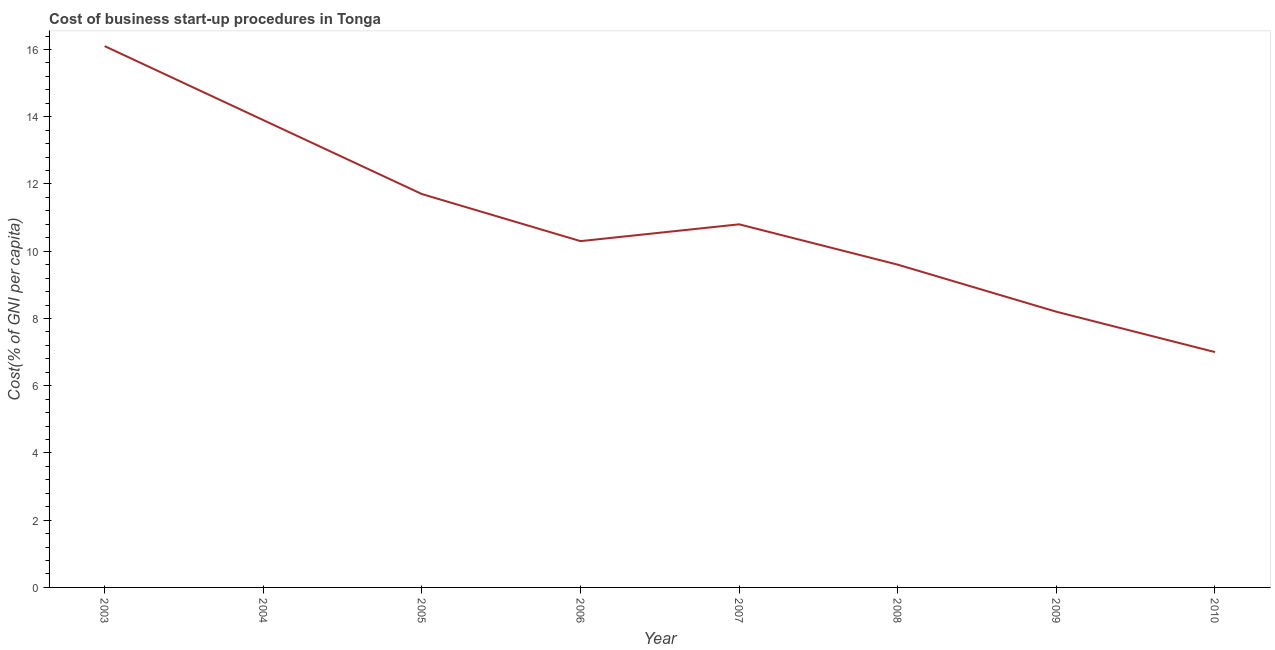What is the cost of business startup procedures in 2007?
Make the answer very short. 10.8. Across all years, what is the maximum cost of business startup procedures?
Your response must be concise. 16.1. Across all years, what is the minimum cost of business startup procedures?
Your response must be concise. 7. What is the sum of the cost of business startup procedures?
Your answer should be compact. 87.6. What is the difference between the cost of business startup procedures in 2005 and 2008?
Your answer should be compact. 2.1. What is the average cost of business startup procedures per year?
Make the answer very short. 10.95. What is the median cost of business startup procedures?
Your response must be concise. 10.55. What is the ratio of the cost of business startup procedures in 2004 to that in 2009?
Offer a very short reply. 1.7. Is the difference between the cost of business startup procedures in 2008 and 2010 greater than the difference between any two years?
Keep it short and to the point. No. What is the difference between the highest and the second highest cost of business startup procedures?
Give a very brief answer. 2.2. Is the sum of the cost of business startup procedures in 2003 and 2005 greater than the maximum cost of business startup procedures across all years?
Offer a terse response. Yes. What is the difference between the highest and the lowest cost of business startup procedures?
Offer a very short reply. 9.1. Does the cost of business startup procedures monotonically increase over the years?
Your response must be concise. No. How many lines are there?
Offer a very short reply. 1. What is the difference between two consecutive major ticks on the Y-axis?
Provide a succinct answer. 2. Does the graph contain any zero values?
Offer a very short reply. No. Does the graph contain grids?
Your answer should be compact. No. What is the title of the graph?
Your response must be concise. Cost of business start-up procedures in Tonga. What is the label or title of the Y-axis?
Give a very brief answer. Cost(% of GNI per capita). What is the Cost(% of GNI per capita) of 2004?
Ensure brevity in your answer.  13.9. What is the Cost(% of GNI per capita) in 2006?
Make the answer very short. 10.3. What is the Cost(% of GNI per capita) in 2007?
Provide a short and direct response. 10.8. What is the Cost(% of GNI per capita) in 2009?
Your answer should be compact. 8.2. What is the Cost(% of GNI per capita) of 2010?
Offer a terse response. 7. What is the difference between the Cost(% of GNI per capita) in 2003 and 2004?
Make the answer very short. 2.2. What is the difference between the Cost(% of GNI per capita) in 2003 and 2006?
Offer a very short reply. 5.8. What is the difference between the Cost(% of GNI per capita) in 2003 and 2007?
Offer a terse response. 5.3. What is the difference between the Cost(% of GNI per capita) in 2003 and 2009?
Offer a very short reply. 7.9. What is the difference between the Cost(% of GNI per capita) in 2003 and 2010?
Give a very brief answer. 9.1. What is the difference between the Cost(% of GNI per capita) in 2004 and 2009?
Your answer should be compact. 5.7. What is the difference between the Cost(% of GNI per capita) in 2004 and 2010?
Give a very brief answer. 6.9. What is the difference between the Cost(% of GNI per capita) in 2005 and 2007?
Offer a very short reply. 0.9. What is the difference between the Cost(% of GNI per capita) in 2005 and 2008?
Your response must be concise. 2.1. What is the difference between the Cost(% of GNI per capita) in 2005 and 2010?
Make the answer very short. 4.7. What is the difference between the Cost(% of GNI per capita) in 2006 and 2007?
Your answer should be very brief. -0.5. What is the difference between the Cost(% of GNI per capita) in 2006 and 2008?
Give a very brief answer. 0.7. What is the difference between the Cost(% of GNI per capita) in 2006 and 2009?
Ensure brevity in your answer.  2.1. What is the difference between the Cost(% of GNI per capita) in 2006 and 2010?
Your answer should be very brief. 3.3. What is the difference between the Cost(% of GNI per capita) in 2007 and 2008?
Ensure brevity in your answer.  1.2. What is the difference between the Cost(% of GNI per capita) in 2008 and 2009?
Ensure brevity in your answer.  1.4. What is the ratio of the Cost(% of GNI per capita) in 2003 to that in 2004?
Your answer should be very brief. 1.16. What is the ratio of the Cost(% of GNI per capita) in 2003 to that in 2005?
Offer a very short reply. 1.38. What is the ratio of the Cost(% of GNI per capita) in 2003 to that in 2006?
Give a very brief answer. 1.56. What is the ratio of the Cost(% of GNI per capita) in 2003 to that in 2007?
Give a very brief answer. 1.49. What is the ratio of the Cost(% of GNI per capita) in 2003 to that in 2008?
Offer a terse response. 1.68. What is the ratio of the Cost(% of GNI per capita) in 2003 to that in 2009?
Make the answer very short. 1.96. What is the ratio of the Cost(% of GNI per capita) in 2004 to that in 2005?
Your answer should be very brief. 1.19. What is the ratio of the Cost(% of GNI per capita) in 2004 to that in 2006?
Your answer should be compact. 1.35. What is the ratio of the Cost(% of GNI per capita) in 2004 to that in 2007?
Make the answer very short. 1.29. What is the ratio of the Cost(% of GNI per capita) in 2004 to that in 2008?
Provide a short and direct response. 1.45. What is the ratio of the Cost(% of GNI per capita) in 2004 to that in 2009?
Make the answer very short. 1.7. What is the ratio of the Cost(% of GNI per capita) in 2004 to that in 2010?
Keep it short and to the point. 1.99. What is the ratio of the Cost(% of GNI per capita) in 2005 to that in 2006?
Make the answer very short. 1.14. What is the ratio of the Cost(% of GNI per capita) in 2005 to that in 2007?
Provide a succinct answer. 1.08. What is the ratio of the Cost(% of GNI per capita) in 2005 to that in 2008?
Your answer should be compact. 1.22. What is the ratio of the Cost(% of GNI per capita) in 2005 to that in 2009?
Give a very brief answer. 1.43. What is the ratio of the Cost(% of GNI per capita) in 2005 to that in 2010?
Your answer should be compact. 1.67. What is the ratio of the Cost(% of GNI per capita) in 2006 to that in 2007?
Provide a short and direct response. 0.95. What is the ratio of the Cost(% of GNI per capita) in 2006 to that in 2008?
Give a very brief answer. 1.07. What is the ratio of the Cost(% of GNI per capita) in 2006 to that in 2009?
Make the answer very short. 1.26. What is the ratio of the Cost(% of GNI per capita) in 2006 to that in 2010?
Make the answer very short. 1.47. What is the ratio of the Cost(% of GNI per capita) in 2007 to that in 2008?
Offer a very short reply. 1.12. What is the ratio of the Cost(% of GNI per capita) in 2007 to that in 2009?
Your response must be concise. 1.32. What is the ratio of the Cost(% of GNI per capita) in 2007 to that in 2010?
Offer a very short reply. 1.54. What is the ratio of the Cost(% of GNI per capita) in 2008 to that in 2009?
Your answer should be very brief. 1.17. What is the ratio of the Cost(% of GNI per capita) in 2008 to that in 2010?
Make the answer very short. 1.37. What is the ratio of the Cost(% of GNI per capita) in 2009 to that in 2010?
Provide a succinct answer. 1.17. 